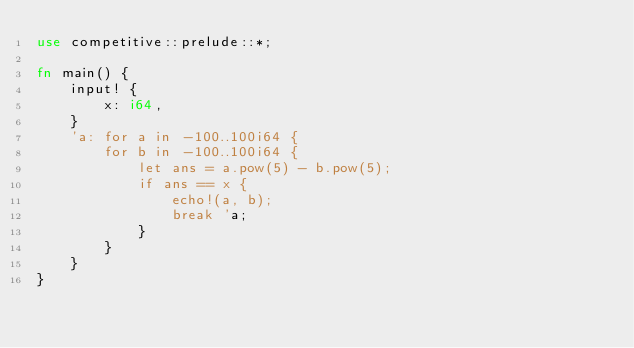Convert code to text. <code><loc_0><loc_0><loc_500><loc_500><_Rust_>use competitive::prelude::*;

fn main() {
    input! {
        x: i64,
    }
    'a: for a in -100..100i64 {
        for b in -100..100i64 {
            let ans = a.pow(5) - b.pow(5);
            if ans == x {
                echo!(a, b);
                break 'a;
            }
        }
    }
}
</code> 